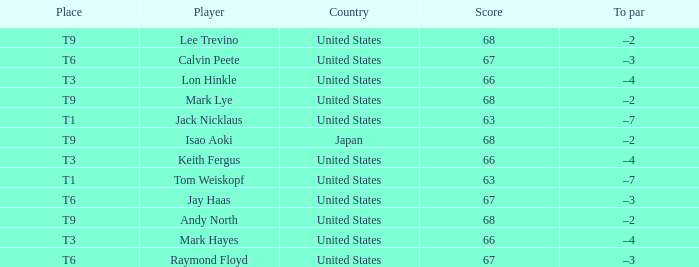What is the Country, when Place is T6, and when Player is "Raymond Floyd"? United States. 